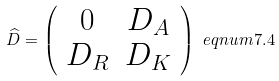Convert formula to latex. <formula><loc_0><loc_0><loc_500><loc_500>\widehat { D } = \left ( \begin{array} { c c } 0 & D _ { A } \\ D _ { R } & D _ { K } \end{array} \right ) \ e q n u m { 7 . 4 }</formula> 